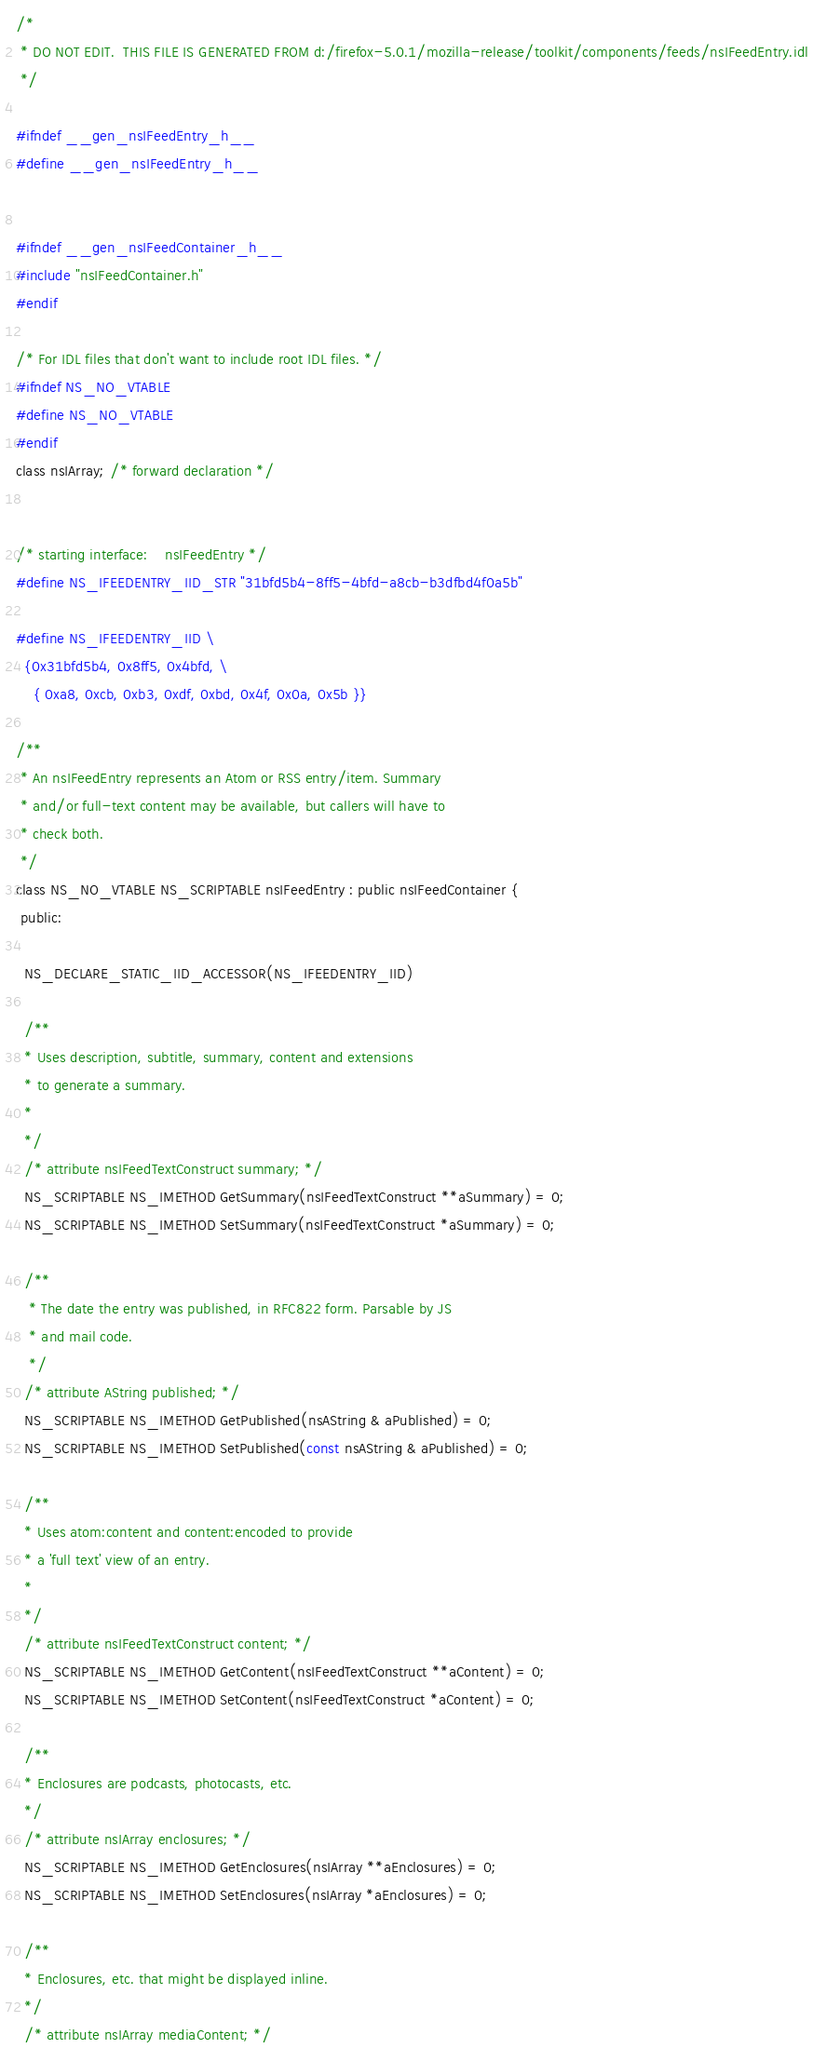Convert code to text. <code><loc_0><loc_0><loc_500><loc_500><_C_>/*
 * DO NOT EDIT.  THIS FILE IS GENERATED FROM d:/firefox-5.0.1/mozilla-release/toolkit/components/feeds/nsIFeedEntry.idl
 */

#ifndef __gen_nsIFeedEntry_h__
#define __gen_nsIFeedEntry_h__


#ifndef __gen_nsIFeedContainer_h__
#include "nsIFeedContainer.h"
#endif

/* For IDL files that don't want to include root IDL files. */
#ifndef NS_NO_VTABLE
#define NS_NO_VTABLE
#endif
class nsIArray; /* forward declaration */


/* starting interface:    nsIFeedEntry */
#define NS_IFEEDENTRY_IID_STR "31bfd5b4-8ff5-4bfd-a8cb-b3dfbd4f0a5b"

#define NS_IFEEDENTRY_IID \
  {0x31bfd5b4, 0x8ff5, 0x4bfd, \
    { 0xa8, 0xcb, 0xb3, 0xdf, 0xbd, 0x4f, 0x0a, 0x5b }}

/**
 * An nsIFeedEntry represents an Atom or RSS entry/item. Summary
 * and/or full-text content may be available, but callers will have to
 * check both.
 */
class NS_NO_VTABLE NS_SCRIPTABLE nsIFeedEntry : public nsIFeedContainer {
 public: 

  NS_DECLARE_STATIC_IID_ACCESSOR(NS_IFEEDENTRY_IID)

  /**
  * Uses description, subtitle, summary, content and extensions
  * to generate a summary. 
  * 
  */
  /* attribute nsIFeedTextConstruct summary; */
  NS_SCRIPTABLE NS_IMETHOD GetSummary(nsIFeedTextConstruct **aSummary) = 0;
  NS_SCRIPTABLE NS_IMETHOD SetSummary(nsIFeedTextConstruct *aSummary) = 0;

  /**
   * The date the entry was published, in RFC822 form. Parsable by JS
   * and mail code.
   */
  /* attribute AString published; */
  NS_SCRIPTABLE NS_IMETHOD GetPublished(nsAString & aPublished) = 0;
  NS_SCRIPTABLE NS_IMETHOD SetPublished(const nsAString & aPublished) = 0;

  /**
  * Uses atom:content and content:encoded to provide
  * a 'full text' view of an entry.
  *
  */
  /* attribute nsIFeedTextConstruct content; */
  NS_SCRIPTABLE NS_IMETHOD GetContent(nsIFeedTextConstruct **aContent) = 0;
  NS_SCRIPTABLE NS_IMETHOD SetContent(nsIFeedTextConstruct *aContent) = 0;

  /**
  * Enclosures are podcasts, photocasts, etc.
  */
  /* attribute nsIArray enclosures; */
  NS_SCRIPTABLE NS_IMETHOD GetEnclosures(nsIArray **aEnclosures) = 0;
  NS_SCRIPTABLE NS_IMETHOD SetEnclosures(nsIArray *aEnclosures) = 0;

  /**
  * Enclosures, etc. that might be displayed inline.
  */
  /* attribute nsIArray mediaContent; */</code> 